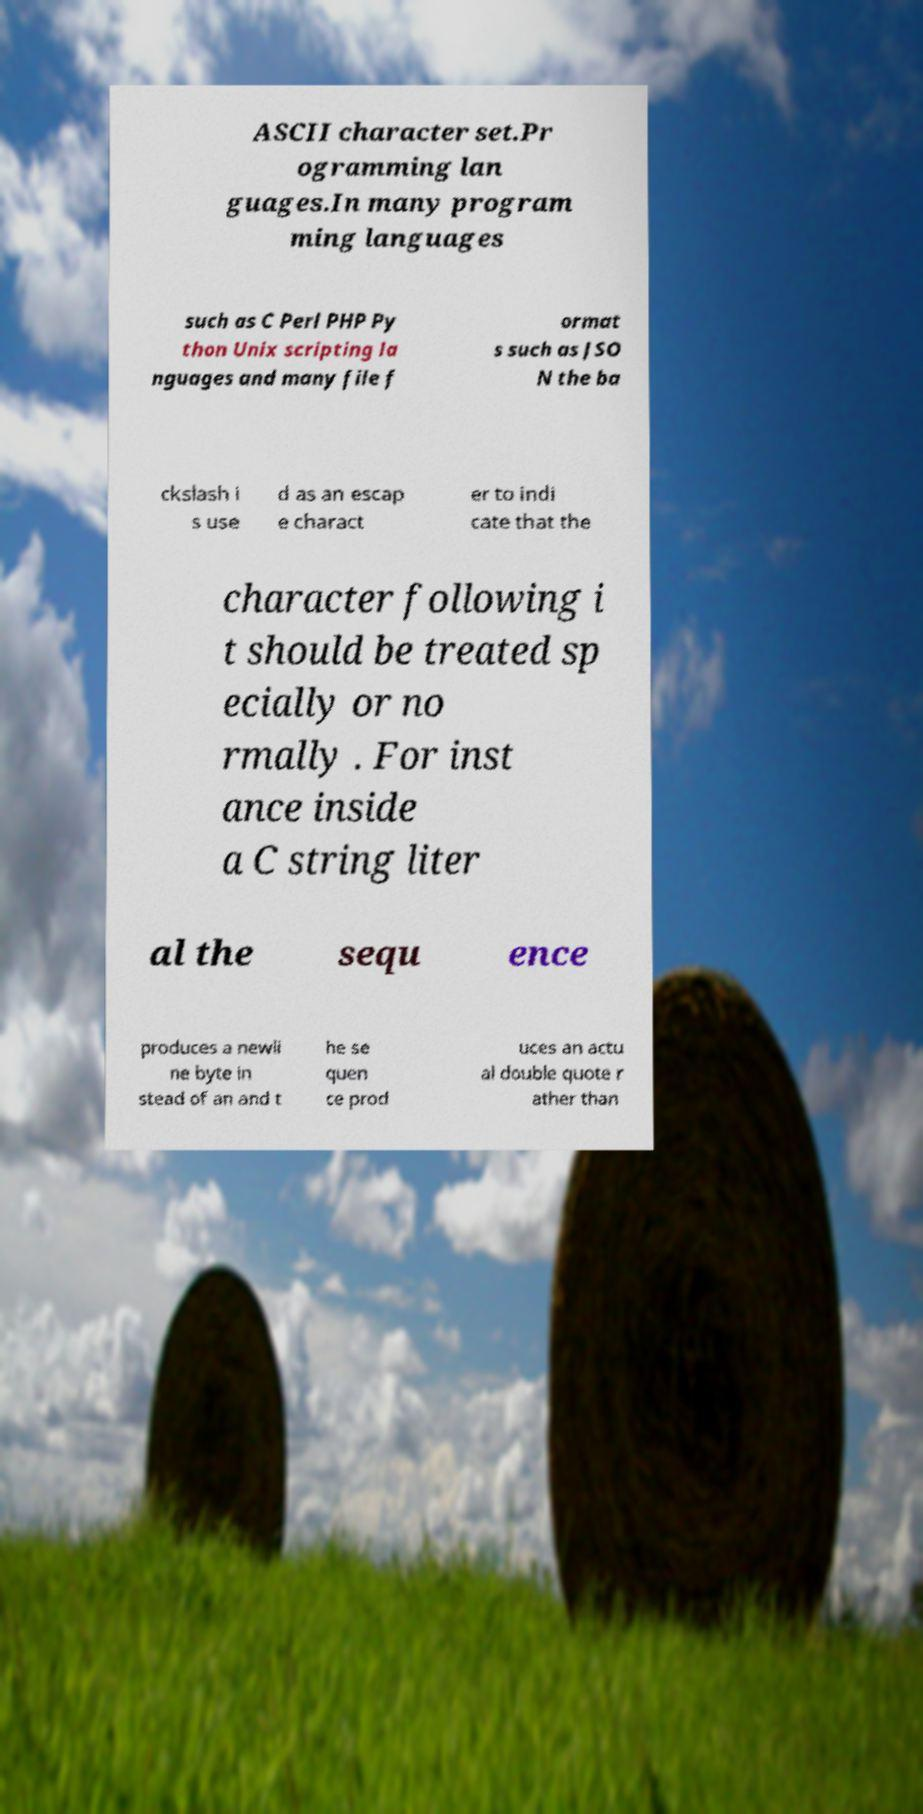For documentation purposes, I need the text within this image transcribed. Could you provide that? ASCII character set.Pr ogramming lan guages.In many program ming languages such as C Perl PHP Py thon Unix scripting la nguages and many file f ormat s such as JSO N the ba ckslash i s use d as an escap e charact er to indi cate that the character following i t should be treated sp ecially or no rmally . For inst ance inside a C string liter al the sequ ence produces a newli ne byte in stead of an and t he se quen ce prod uces an actu al double quote r ather than 